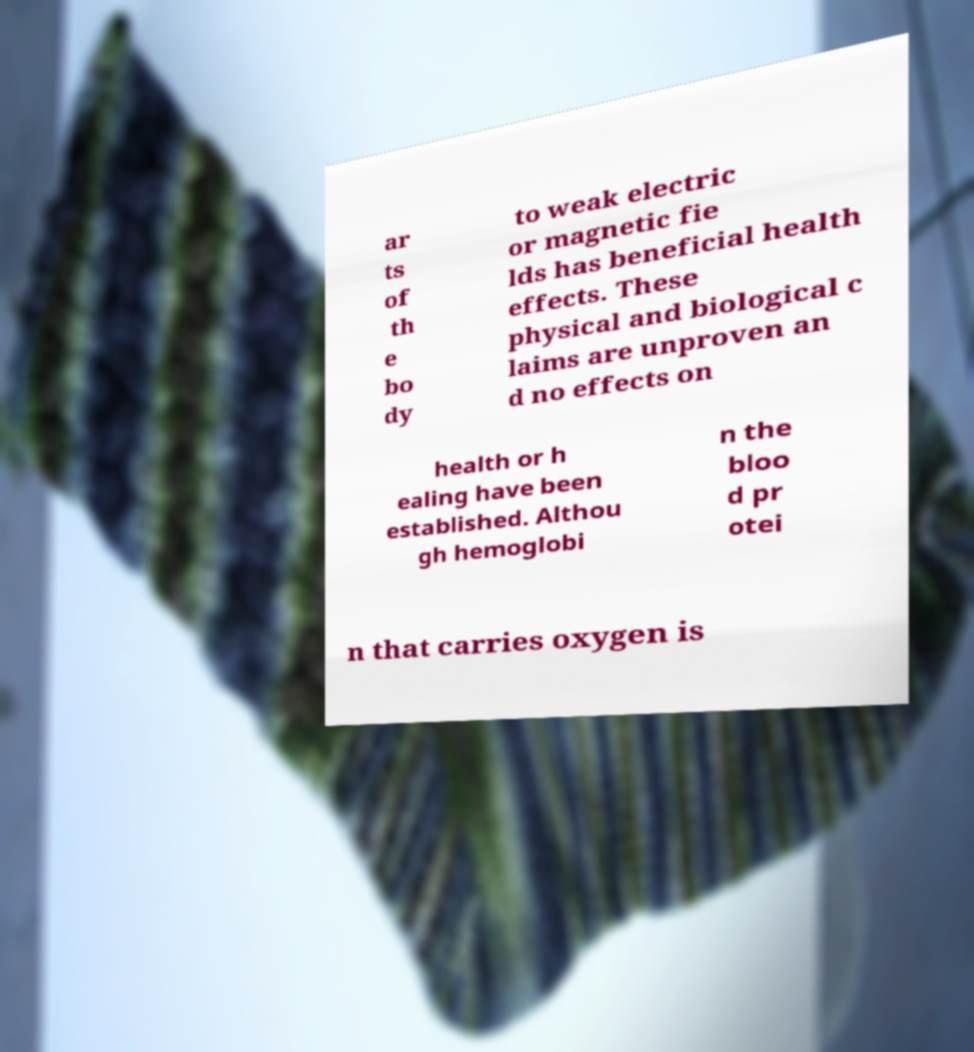Could you extract and type out the text from this image? ar ts of th e bo dy to weak electric or magnetic fie lds has beneficial health effects. These physical and biological c laims are unproven an d no effects on health or h ealing have been established. Althou gh hemoglobi n the bloo d pr otei n that carries oxygen is 